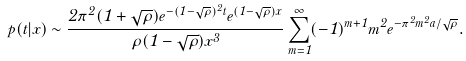<formula> <loc_0><loc_0><loc_500><loc_500>p ( t | x ) \sim \frac { 2 \pi ^ { 2 } ( 1 + \sqrt { \rho } ) e ^ { - ( 1 - \sqrt { \rho } ) ^ { 2 } t } e ^ { ( 1 - \sqrt { \rho } ) x } } { \rho ( 1 - \sqrt { \rho } ) x ^ { 3 } } \sum _ { m = 1 } ^ { \infty } ( - 1 ) ^ { m + 1 } m ^ { 2 } e ^ { - \pi ^ { 2 } m ^ { 2 } a / \sqrt { \rho } } .</formula> 